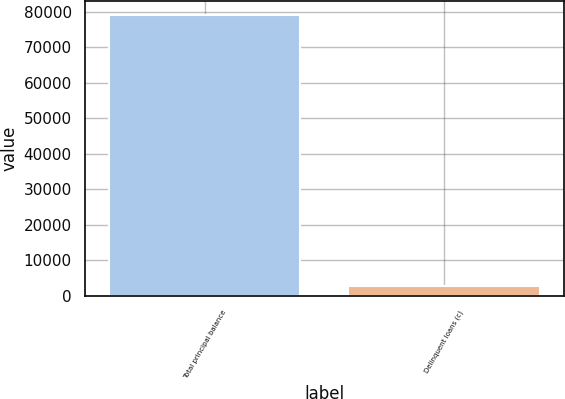<chart> <loc_0><loc_0><loc_500><loc_500><bar_chart><fcel>Total principal balance<fcel>Delinquent loans (c)<nl><fcel>79108<fcel>2657<nl></chart> 